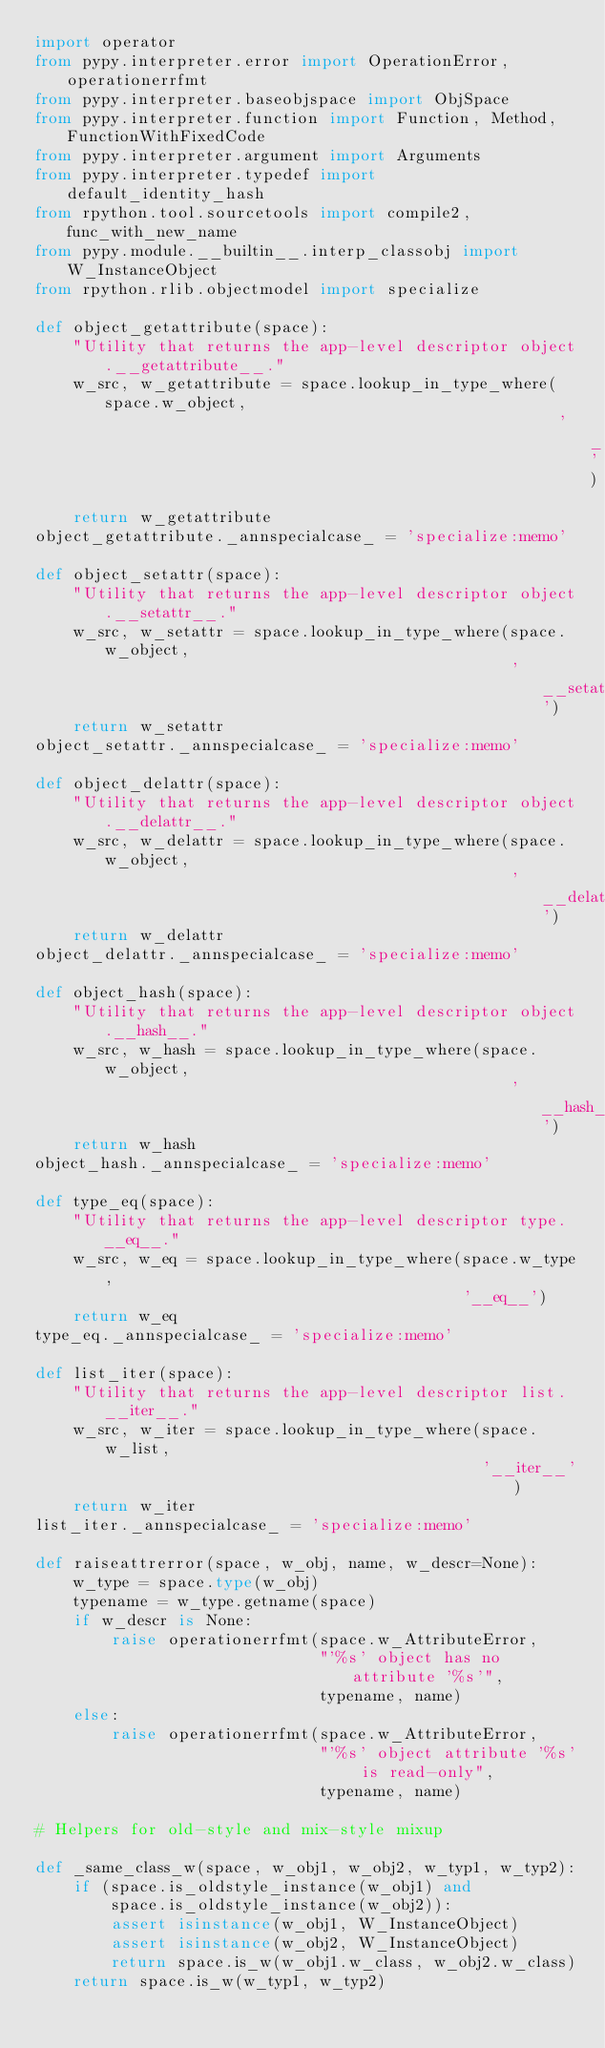<code> <loc_0><loc_0><loc_500><loc_500><_Python_>import operator
from pypy.interpreter.error import OperationError, operationerrfmt
from pypy.interpreter.baseobjspace import ObjSpace
from pypy.interpreter.function import Function, Method, FunctionWithFixedCode
from pypy.interpreter.argument import Arguments
from pypy.interpreter.typedef import default_identity_hash
from rpython.tool.sourcetools import compile2, func_with_new_name
from pypy.module.__builtin__.interp_classobj import W_InstanceObject
from rpython.rlib.objectmodel import specialize

def object_getattribute(space):
    "Utility that returns the app-level descriptor object.__getattribute__."
    w_src, w_getattribute = space.lookup_in_type_where(space.w_object,
                                                       '__getattribute__')
    return w_getattribute
object_getattribute._annspecialcase_ = 'specialize:memo'

def object_setattr(space):
    "Utility that returns the app-level descriptor object.__setattr__."
    w_src, w_setattr = space.lookup_in_type_where(space.w_object,
                                                  '__setattr__')
    return w_setattr
object_setattr._annspecialcase_ = 'specialize:memo'

def object_delattr(space):
    "Utility that returns the app-level descriptor object.__delattr__."
    w_src, w_delattr = space.lookup_in_type_where(space.w_object,
                                                  '__delattr__')
    return w_delattr
object_delattr._annspecialcase_ = 'specialize:memo'

def object_hash(space):
    "Utility that returns the app-level descriptor object.__hash__."
    w_src, w_hash = space.lookup_in_type_where(space.w_object,
                                                  '__hash__')
    return w_hash
object_hash._annspecialcase_ = 'specialize:memo'

def type_eq(space):
    "Utility that returns the app-level descriptor type.__eq__."
    w_src, w_eq = space.lookup_in_type_where(space.w_type,
                                             '__eq__')
    return w_eq
type_eq._annspecialcase_ = 'specialize:memo'

def list_iter(space):
    "Utility that returns the app-level descriptor list.__iter__."
    w_src, w_iter = space.lookup_in_type_where(space.w_list,
                                               '__iter__')
    return w_iter
list_iter._annspecialcase_ = 'specialize:memo'

def raiseattrerror(space, w_obj, name, w_descr=None):
    w_type = space.type(w_obj)
    typename = w_type.getname(space)
    if w_descr is None:
        raise operationerrfmt(space.w_AttributeError,
                              "'%s' object has no attribute '%s'",
                              typename, name)
    else:
        raise operationerrfmt(space.w_AttributeError,
                              "'%s' object attribute '%s' is read-only",
                              typename, name)

# Helpers for old-style and mix-style mixup

def _same_class_w(space, w_obj1, w_obj2, w_typ1, w_typ2):
    if (space.is_oldstyle_instance(w_obj1) and
        space.is_oldstyle_instance(w_obj2)):
        assert isinstance(w_obj1, W_InstanceObject)
        assert isinstance(w_obj2, W_InstanceObject)
        return space.is_w(w_obj1.w_class, w_obj2.w_class)
    return space.is_w(w_typ1, w_typ2)

</code> 